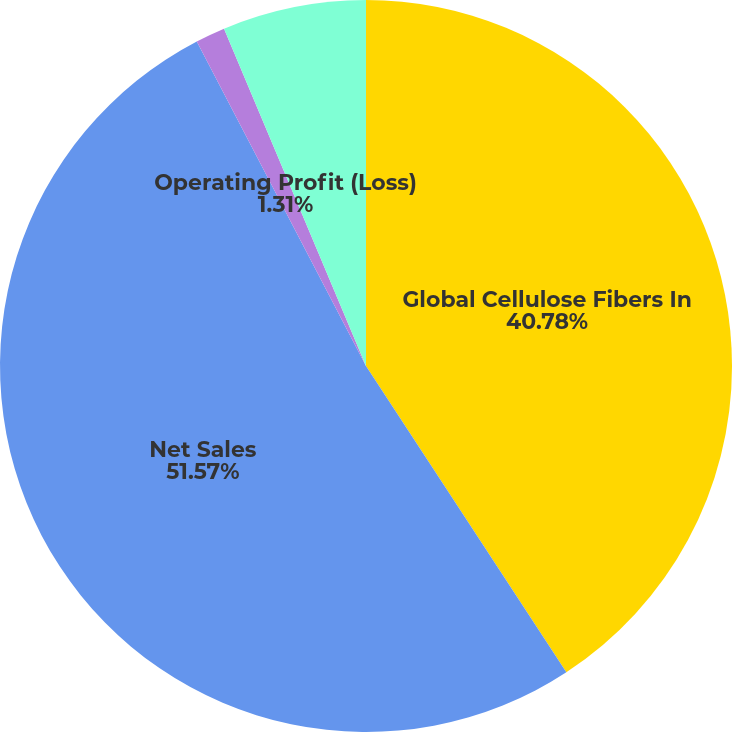Convert chart. <chart><loc_0><loc_0><loc_500><loc_500><pie_chart><fcel>Global Cellulose Fibers In<fcel>Net Sales<fcel>Operating Profit (Loss)<fcel>Operating Profit Before<nl><fcel>40.78%<fcel>51.57%<fcel>1.31%<fcel>6.34%<nl></chart> 